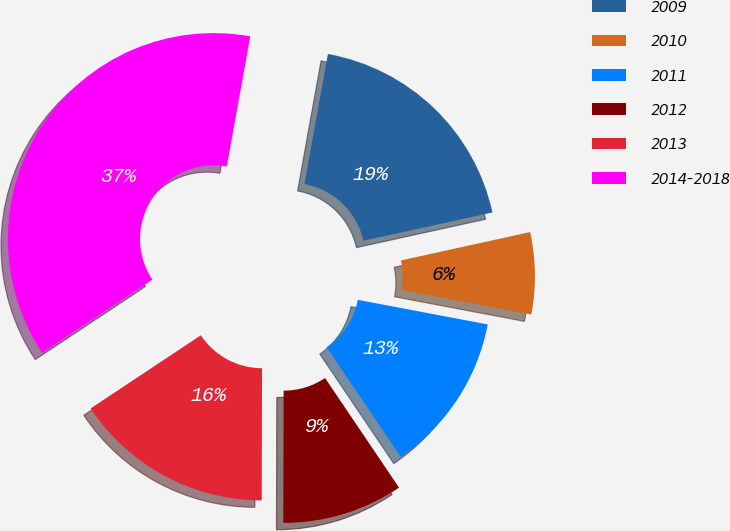Convert chart. <chart><loc_0><loc_0><loc_500><loc_500><pie_chart><fcel>2009<fcel>2010<fcel>2011<fcel>2012<fcel>2013<fcel>2014-2018<nl><fcel>18.72%<fcel>6.42%<fcel>12.57%<fcel>9.49%<fcel>15.64%<fcel>37.16%<nl></chart> 